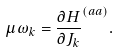Convert formula to latex. <formula><loc_0><loc_0><loc_500><loc_500>\mu \omega _ { k } = \frac { \partial H } { \partial J _ { k } } ^ { ( a a ) } .</formula> 